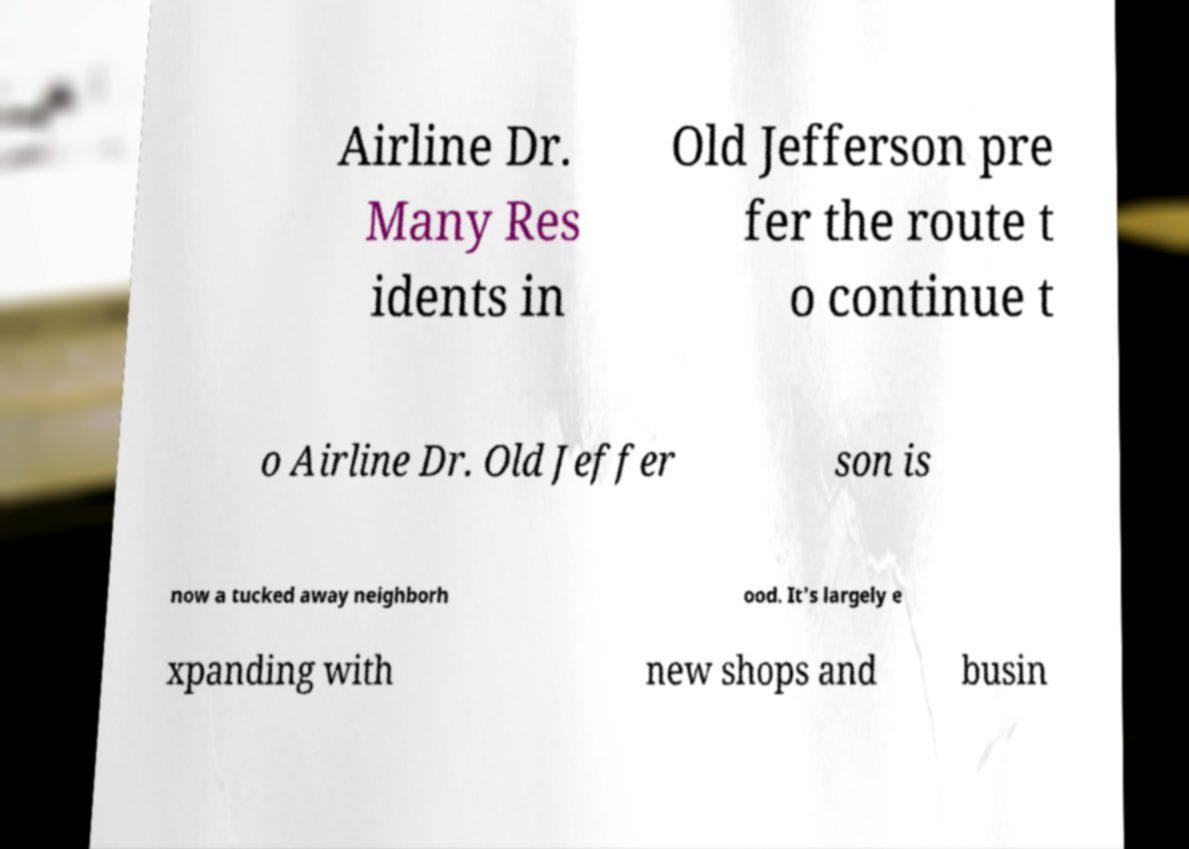Can you accurately transcribe the text from the provided image for me? Airline Dr. Many Res idents in Old Jefferson pre fer the route t o continue t o Airline Dr. Old Jeffer son is now a tucked away neighborh ood. It's largely e xpanding with new shops and busin 